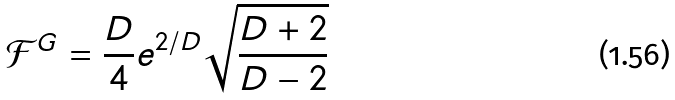Convert formula to latex. <formula><loc_0><loc_0><loc_500><loc_500>\mathcal { F } ^ { G } = \frac { D } { 4 } e ^ { 2 / D } \sqrt { \frac { D + 2 } { D - 2 } }</formula> 